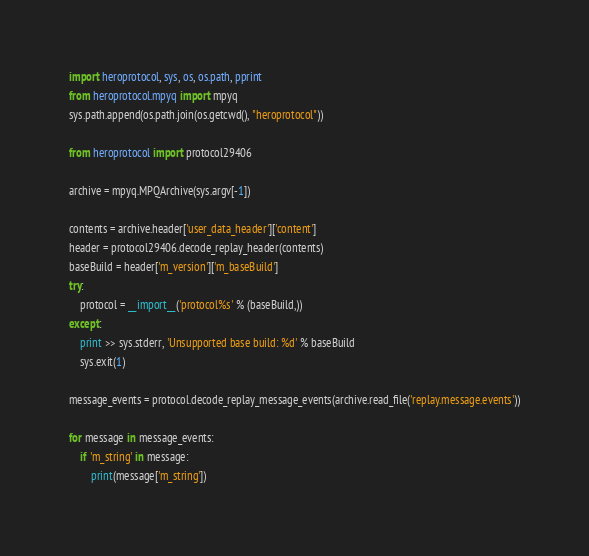<code> <loc_0><loc_0><loc_500><loc_500><_Python_>import heroprotocol, sys, os, os.path, pprint
from heroprotocol.mpyq import mpyq
sys.path.append(os.path.join(os.getcwd(), "heroprotocol"))

from heroprotocol import protocol29406

archive = mpyq.MPQArchive(sys.argv[-1])

contents = archive.header['user_data_header']['content']
header = protocol29406.decode_replay_header(contents)
baseBuild = header['m_version']['m_baseBuild']
try:
    protocol = __import__('protocol%s' % (baseBuild,))
except:
    print >> sys.stderr, 'Unsupported base build: %d' % baseBuild
    sys.exit(1)

message_events = protocol.decode_replay_message_events(archive.read_file('replay.message.events'))

for message in message_events:
    if 'm_string' in message:
        print(message['m_string'])</code> 